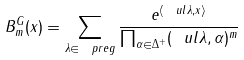Convert formula to latex. <formula><loc_0><loc_0><loc_500><loc_500>B ^ { G } _ { m } ( x ) = \sum _ { \lambda \in \ p r e g } \frac { e ^ { \langle \ u l \lambda , x \rangle } } { \prod _ { \alpha \in \Delta ^ { + } } ( \ u l \lambda , \alpha ) ^ { m } }</formula> 